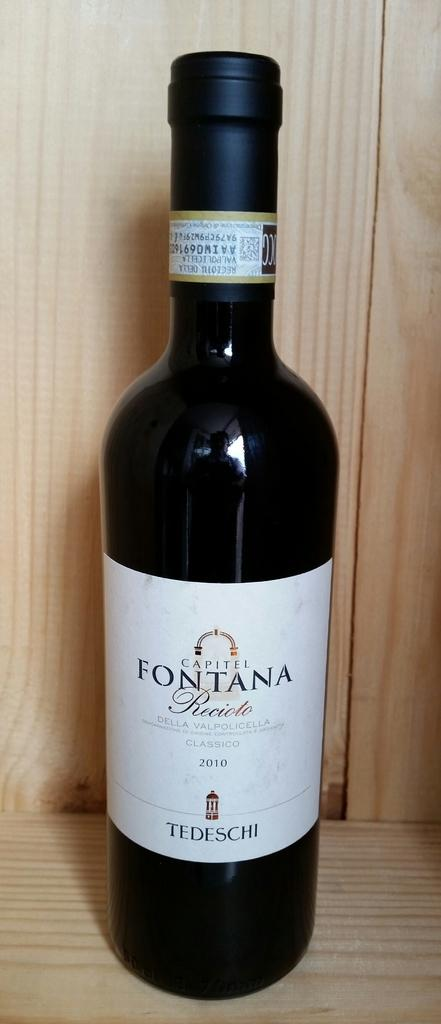<image>
Share a concise interpretation of the image provided. A bottle of Fontana Recioto on a wooden shelf. 